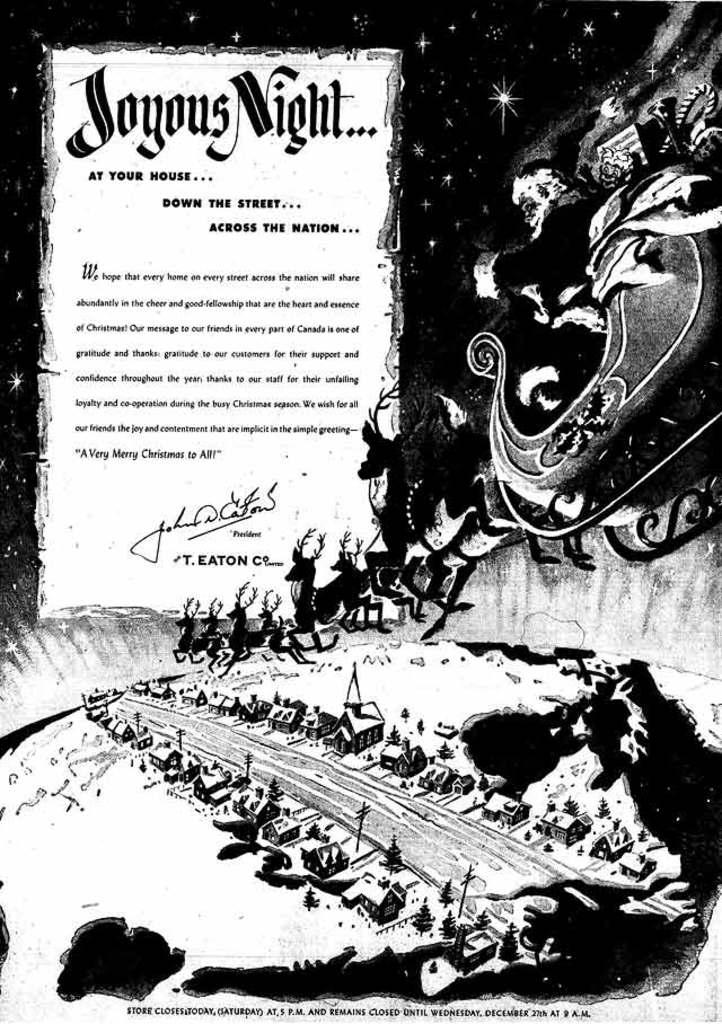<image>
Present a compact description of the photo's key features. The wonderful picture of Santa in black and white speaks of Joyous Night. 